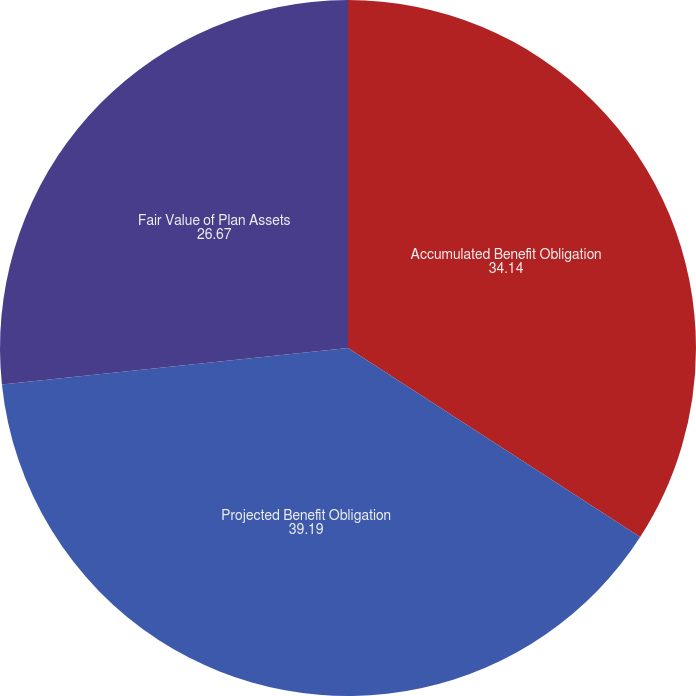Convert chart. <chart><loc_0><loc_0><loc_500><loc_500><pie_chart><fcel>Accumulated Benefit Obligation<fcel>Projected Benefit Obligation<fcel>Fair Value of Plan Assets<nl><fcel>34.14%<fcel>39.19%<fcel>26.67%<nl></chart> 